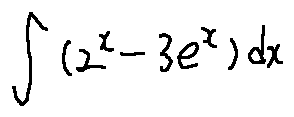Convert formula to latex. <formula><loc_0><loc_0><loc_500><loc_500>\int ( 2 ^ { x } - 3 e ^ { x } ) d x</formula> 